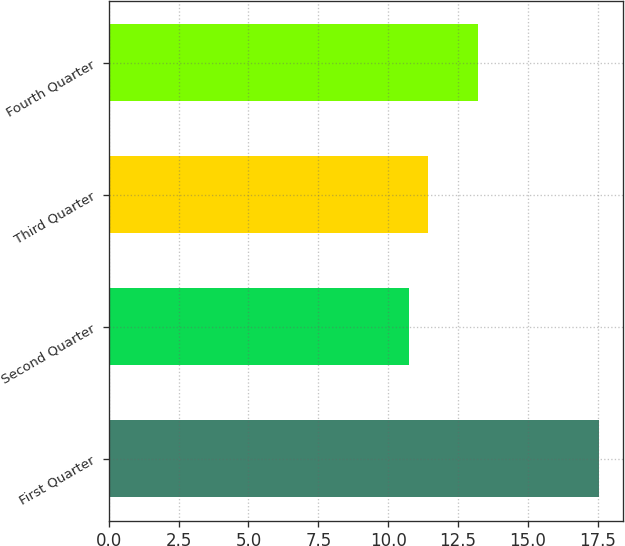Convert chart. <chart><loc_0><loc_0><loc_500><loc_500><bar_chart><fcel>First Quarter<fcel>Second Quarter<fcel>Third Quarter<fcel>Fourth Quarter<nl><fcel>17.54<fcel>10.75<fcel>11.43<fcel>13.21<nl></chart> 